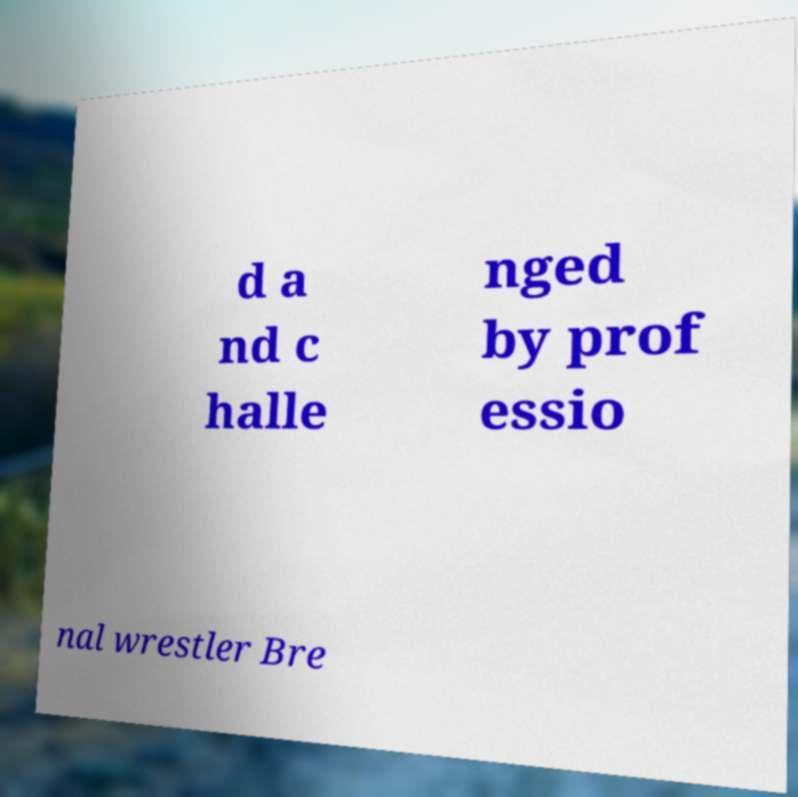Can you accurately transcribe the text from the provided image for me? d a nd c halle nged by prof essio nal wrestler Bre 